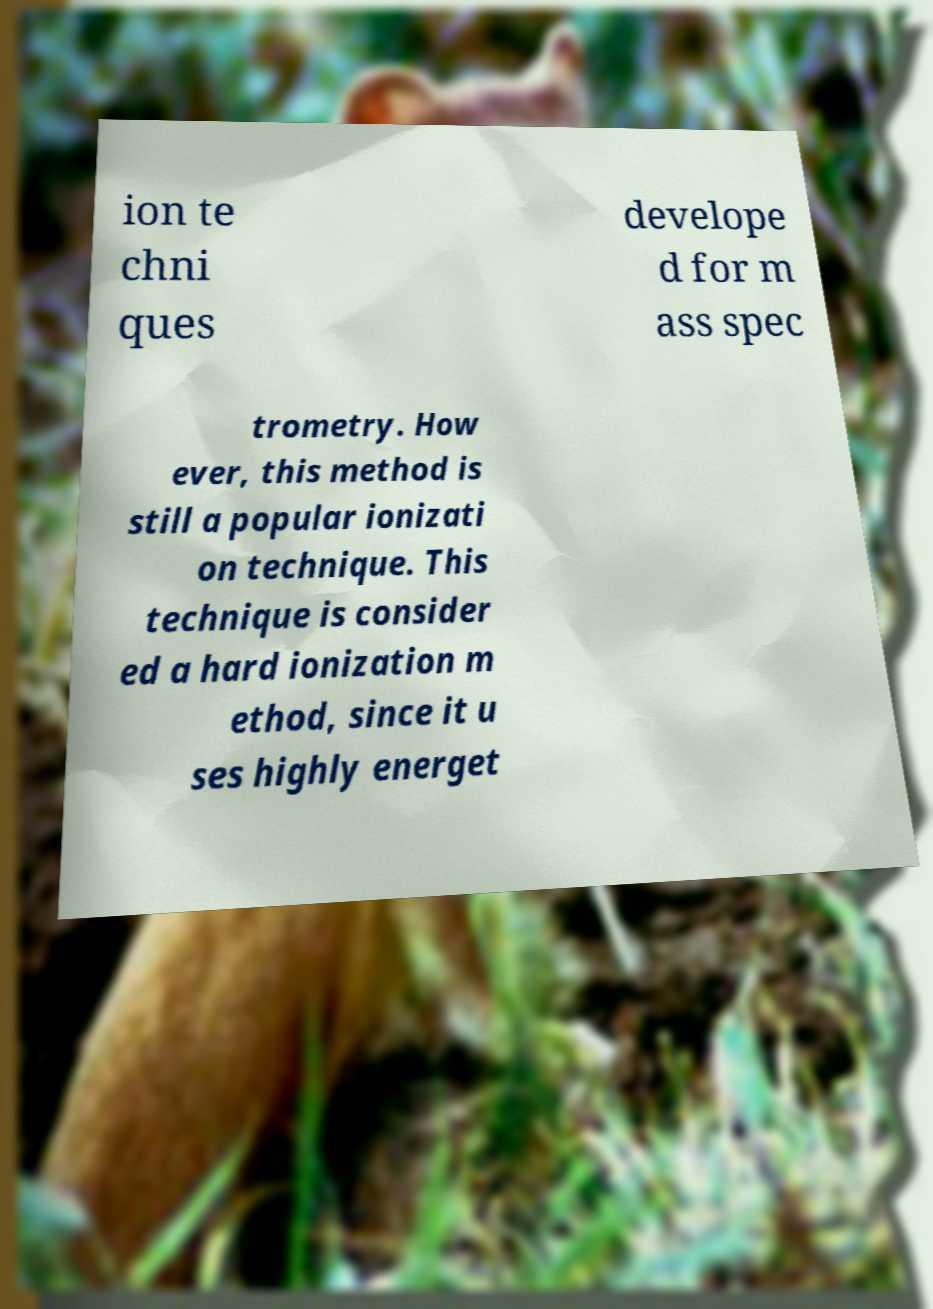Please identify and transcribe the text found in this image. ion te chni ques develope d for m ass spec trometry. How ever, this method is still a popular ionizati on technique. This technique is consider ed a hard ionization m ethod, since it u ses highly energet 